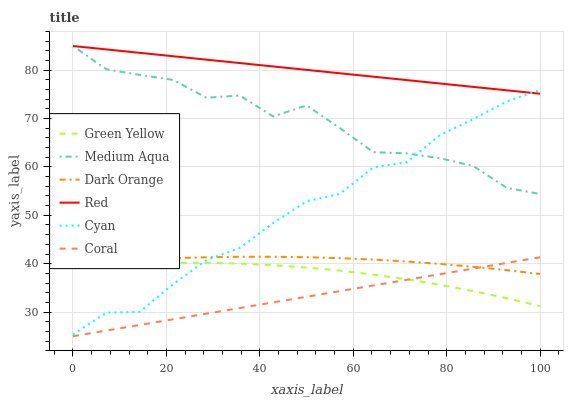Does Coral have the minimum area under the curve?
Answer yes or no. Yes. Does Red have the maximum area under the curve?
Answer yes or no. Yes. Does Medium Aqua have the minimum area under the curve?
Answer yes or no. No. Does Medium Aqua have the maximum area under the curve?
Answer yes or no. No. Is Red the smoothest?
Answer yes or no. Yes. Is Medium Aqua the roughest?
Answer yes or no. Yes. Is Coral the smoothest?
Answer yes or no. No. Is Coral the roughest?
Answer yes or no. No. Does Coral have the lowest value?
Answer yes or no. Yes. Does Medium Aqua have the lowest value?
Answer yes or no. No. Does Red have the highest value?
Answer yes or no. Yes. Does Coral have the highest value?
Answer yes or no. No. Is Green Yellow less than Medium Aqua?
Answer yes or no. Yes. Is Medium Aqua greater than Coral?
Answer yes or no. Yes. Does Cyan intersect Dark Orange?
Answer yes or no. Yes. Is Cyan less than Dark Orange?
Answer yes or no. No. Is Cyan greater than Dark Orange?
Answer yes or no. No. Does Green Yellow intersect Medium Aqua?
Answer yes or no. No. 